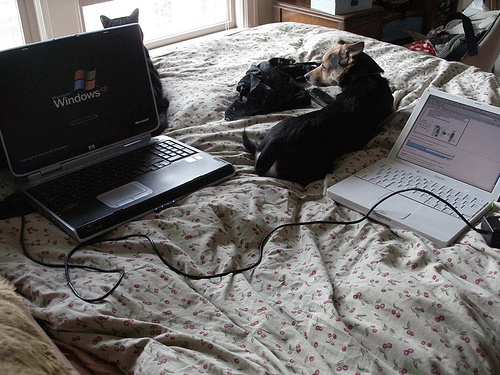Describe the objects in this image and their specific colors. I can see bed in white, darkgray, gray, black, and lightgray tones, laptop in white, black, lightgray, gray, and darkgray tones, laptop in white, darkgray, and gray tones, dog in white, black, gray, and darkgray tones, and chair in white, black, and gray tones in this image. 